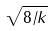<formula> <loc_0><loc_0><loc_500><loc_500>\sqrt { 8 / k }</formula> 